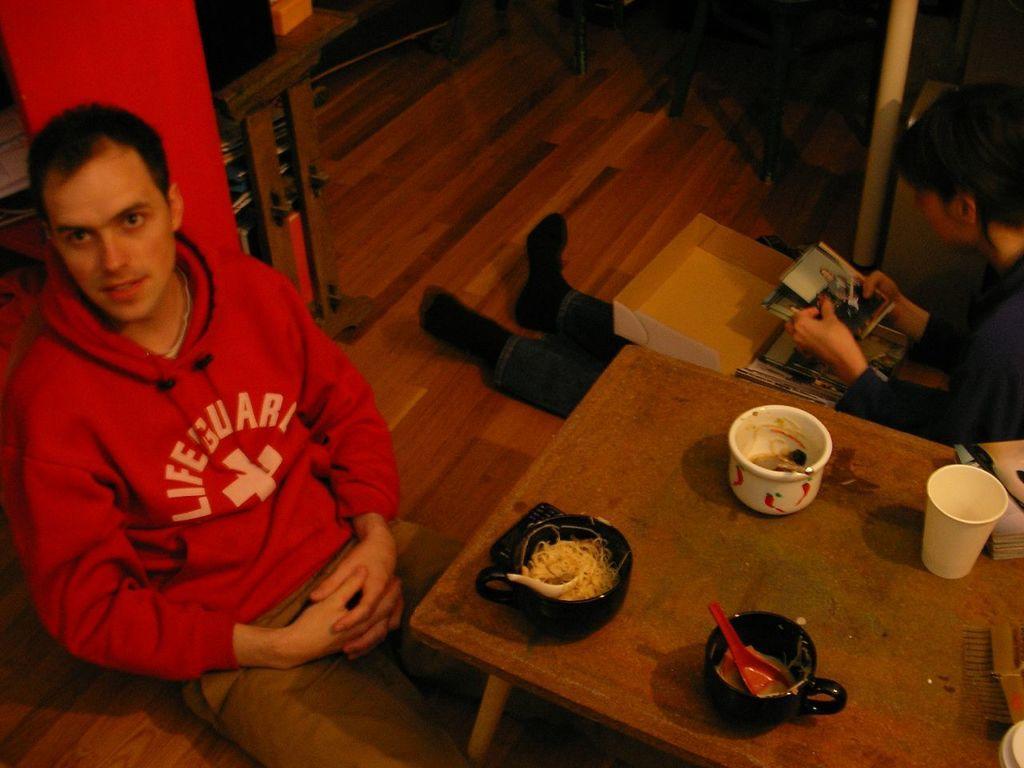Can you describe this image briefly? In this image on the left side there is one man who is sitting and he is wearing a red shirt in front of him there is one table on that table there are two cups and one bowl and spoon and one glass is there on the table and on the top of the right corner there is another person who is sitting and he is looking at photos and on the top there is a wooden floor. 